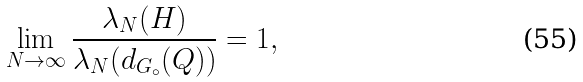<formula> <loc_0><loc_0><loc_500><loc_500>\lim _ { N \to \infty } \frac { \lambda _ { N } ( H ) } { \lambda _ { N } ( d _ { G _ { \circ } } ( Q ) ) } = 1 ,</formula> 